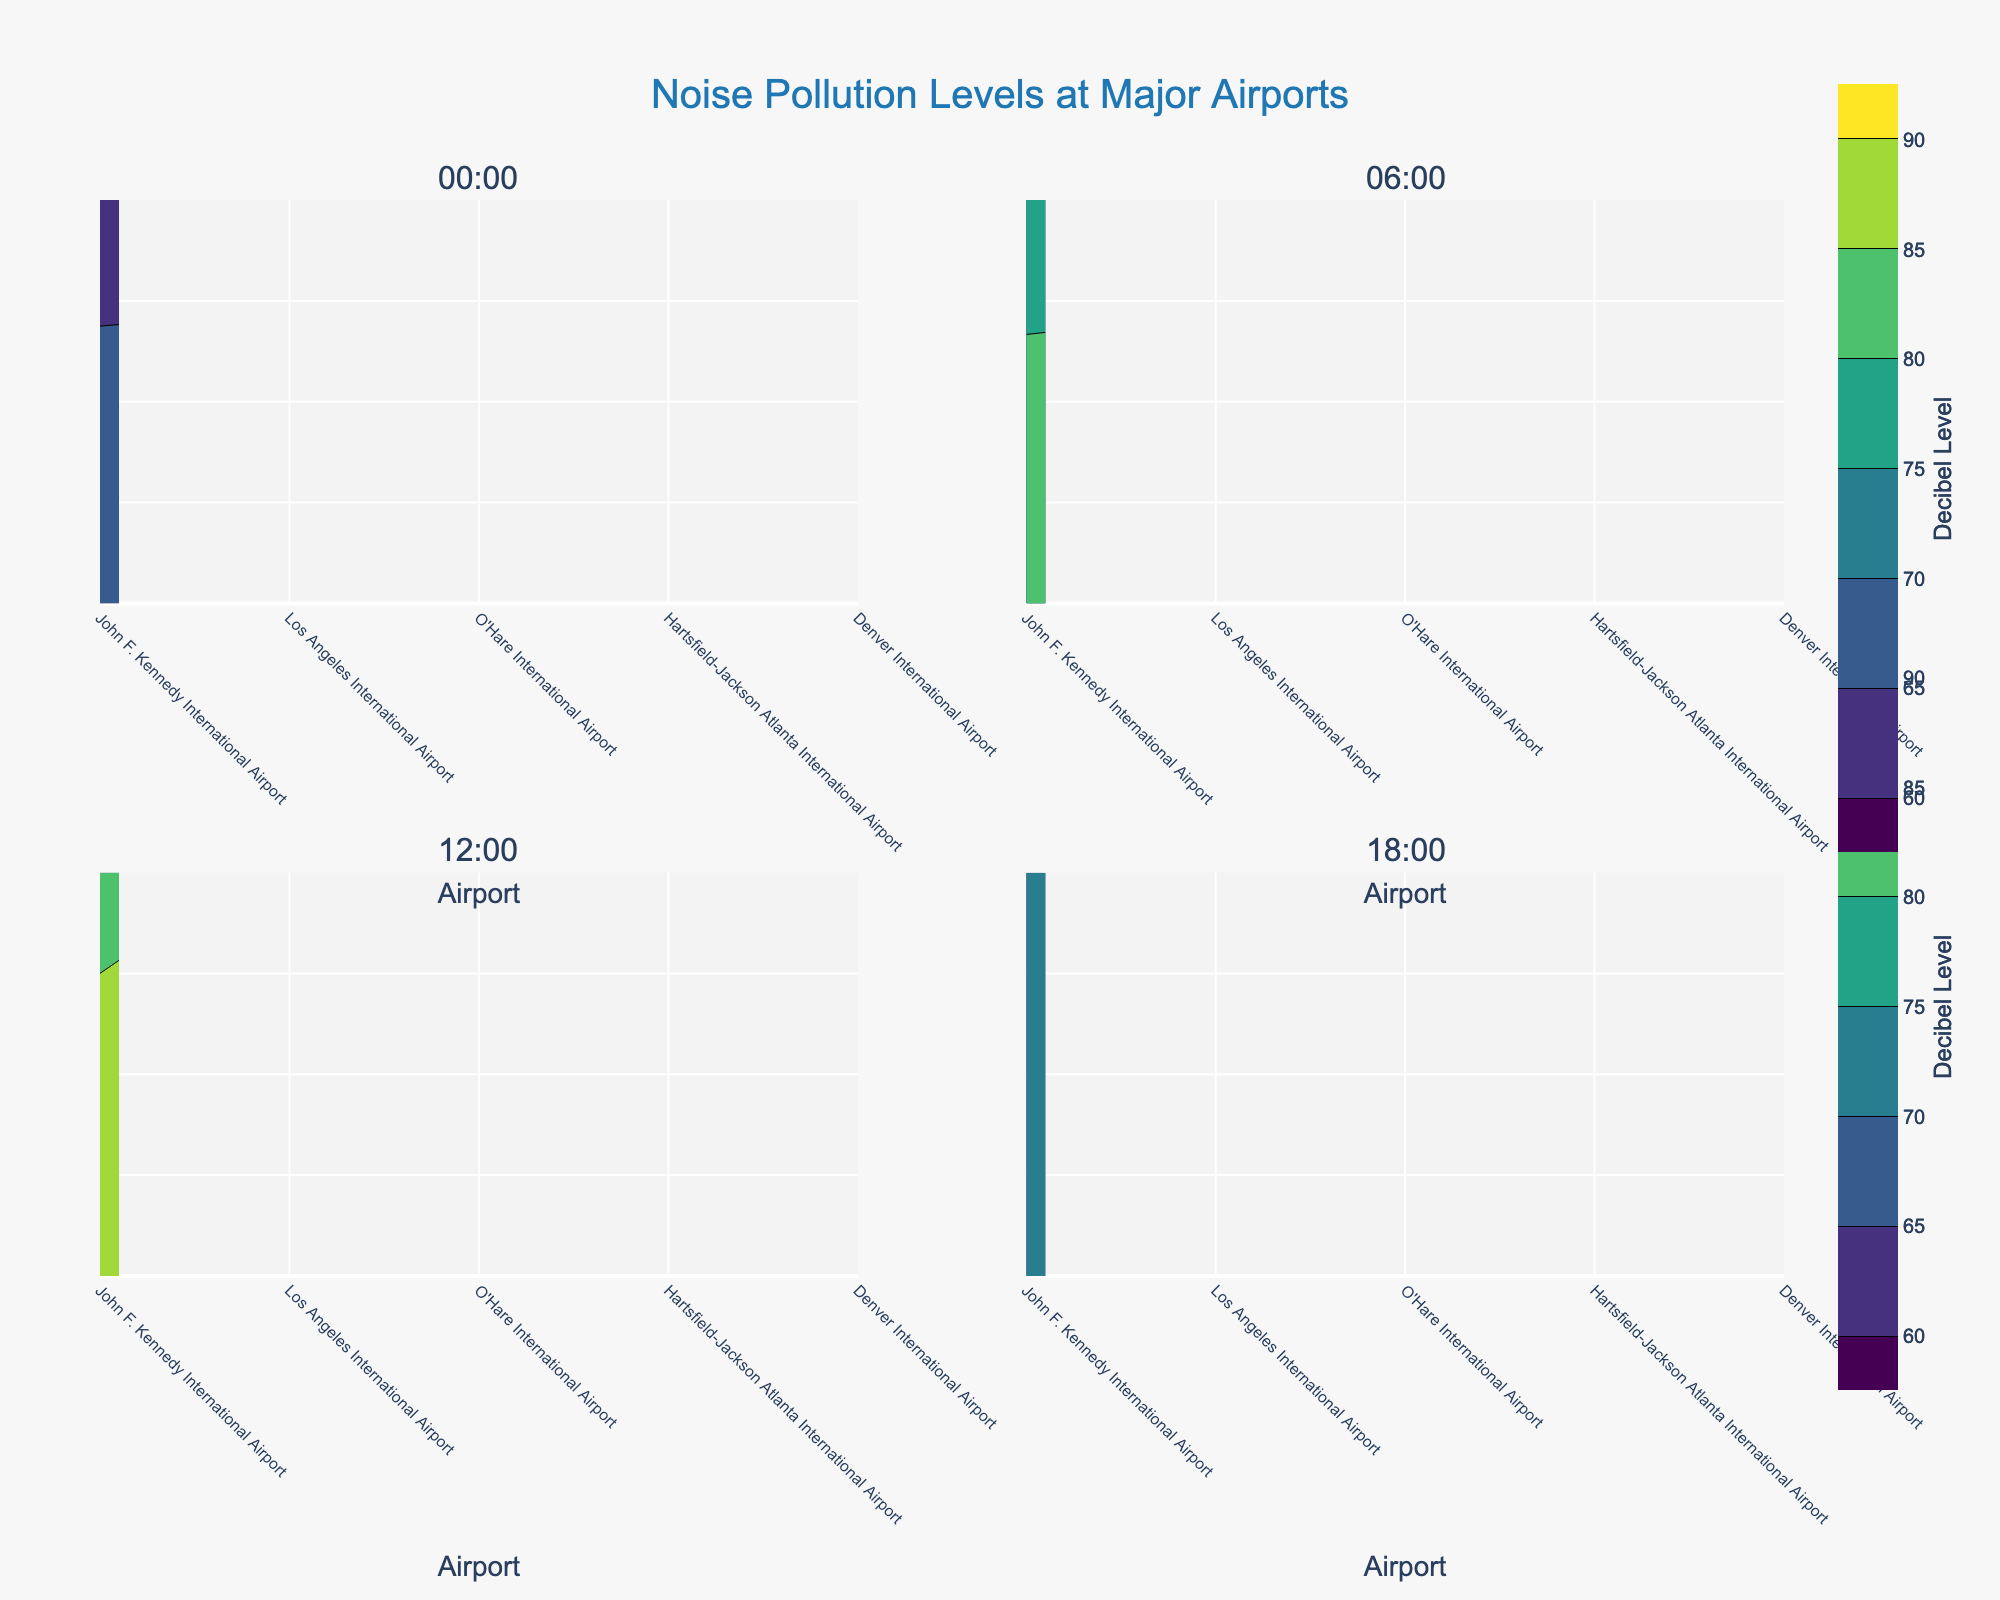Which airport has the highest decibel level at 06:00? To find the airport with the highest decibel level at 06:00, look for the highest contour value in the subplot labeled 06:00. The highest level is at John F. Kennedy International Airport.
Answer: John F. Kennedy International Airport How do noise levels at John F. Kennedy International Airport compare between 00:00 and 12:00? Compare the contour values for John F. Kennedy International Airport in the subplots labeled 00:00 and 12:00. At 00:00, the noise level is 70 dB, while at 12:00, it is 90 dB, showing an increase.
Answer: 70 dB to 90 dB What's the difference in decibel levels between Los Angeles International Airport and Denver International Airport at 18:00? Look at the subplot labeled 18:00 and find the contour values for Los Angeles International Airport and Denver International Airport. Los Angeles is at 73 dB and Denver is at 70 dB. The difference is 73 - 70 = 3 dB.
Answer: 3 dB Which time of day has the lowest overall decibel levels across the airports? Compare the minimum contour values across all the subplots. The lowest decibel levels overall appear in the subplot labeled 00:00.
Answer: 00:00 What's the average decibel level for Hartsfield-Jackson Atlanta International Airport across all times of day? List the decibel levels for Hartsfield-Jackson Atlanta International Airport: 64, 79, 85, 71. Calculate the average by summing these values (64 + 79 + 85 + 71) and dividing by 4. (299 / 4 = 74.75)
Answer: 74.75 dB At which airport and time of day do the noise levels exceed 85 dB? Identify the subplots where decibel levels exceed 85 dB. JFK exceeds 85 dB at both 06:00 and 12:00, while Los Angeles, O'Hare, and Hartsfield-Jackson also exceed 85 dB at 12:00.
Answer: JFK at 06:00 and 12:00; Los Angeles, O'Hare, Hartsfield-Jackson at 12:00 